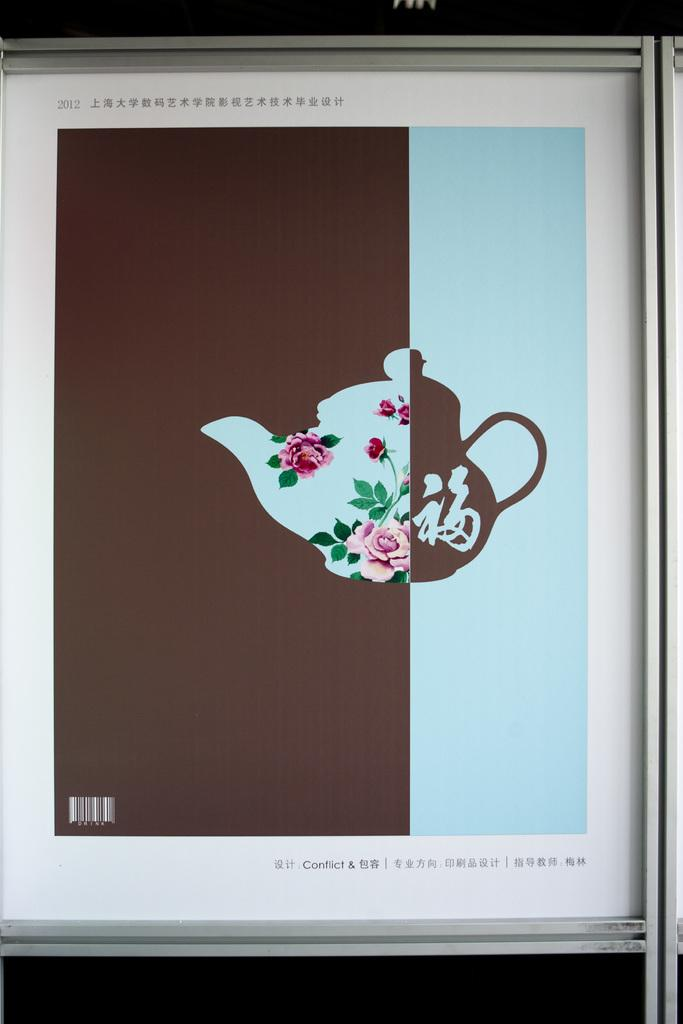Provide a one-sentence caption for the provided image. a tea pot on a screen with the word conflict on it. 